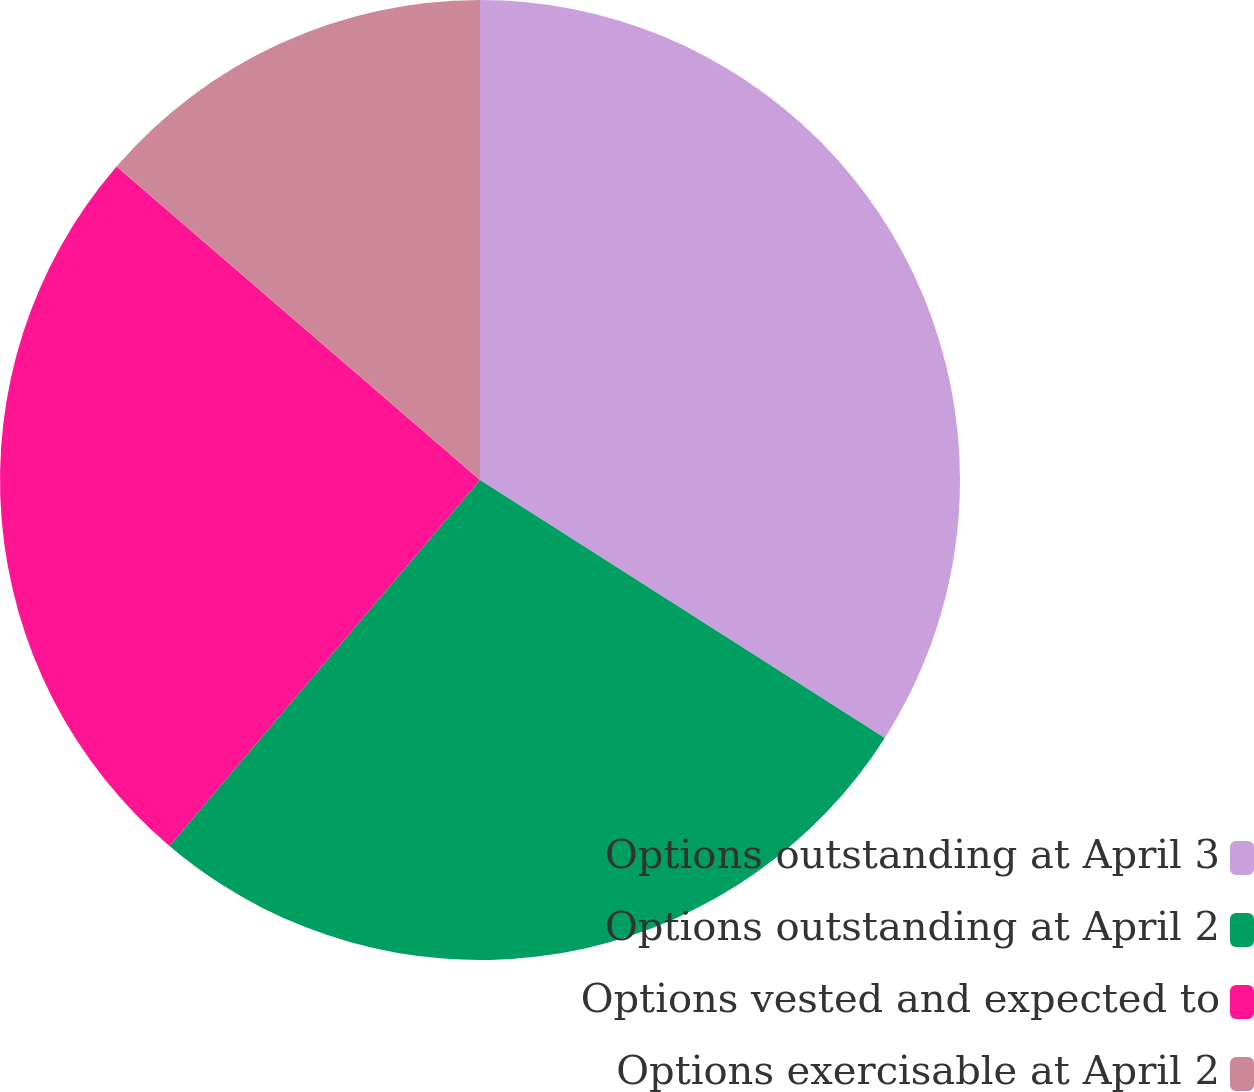Convert chart to OTSL. <chart><loc_0><loc_0><loc_500><loc_500><pie_chart><fcel>Options outstanding at April 3<fcel>Options outstanding at April 2<fcel>Options vested and expected to<fcel>Options exercisable at April 2<nl><fcel>34.03%<fcel>27.17%<fcel>25.13%<fcel>13.67%<nl></chart> 